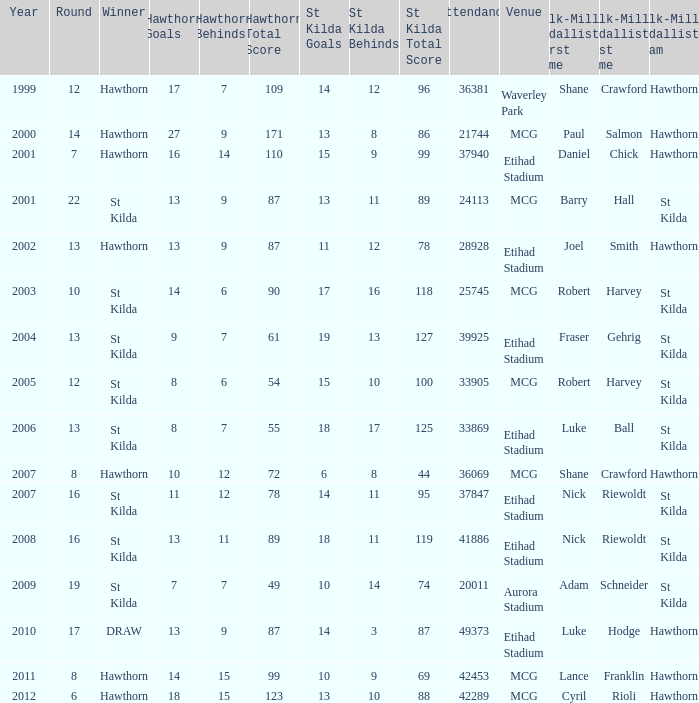How many winners have st kilda score at 14.11.95? 1.0. 